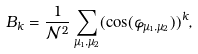<formula> <loc_0><loc_0><loc_500><loc_500>B _ { k } = \frac { 1 } { \mathcal { N } ^ { 2 } } \sum _ { \mu _ { 1 } , \mu _ { 2 } } ( \cos ( \varphi _ { \mu _ { 1 } , \mu _ { 2 } } ) ) ^ { k } ,</formula> 